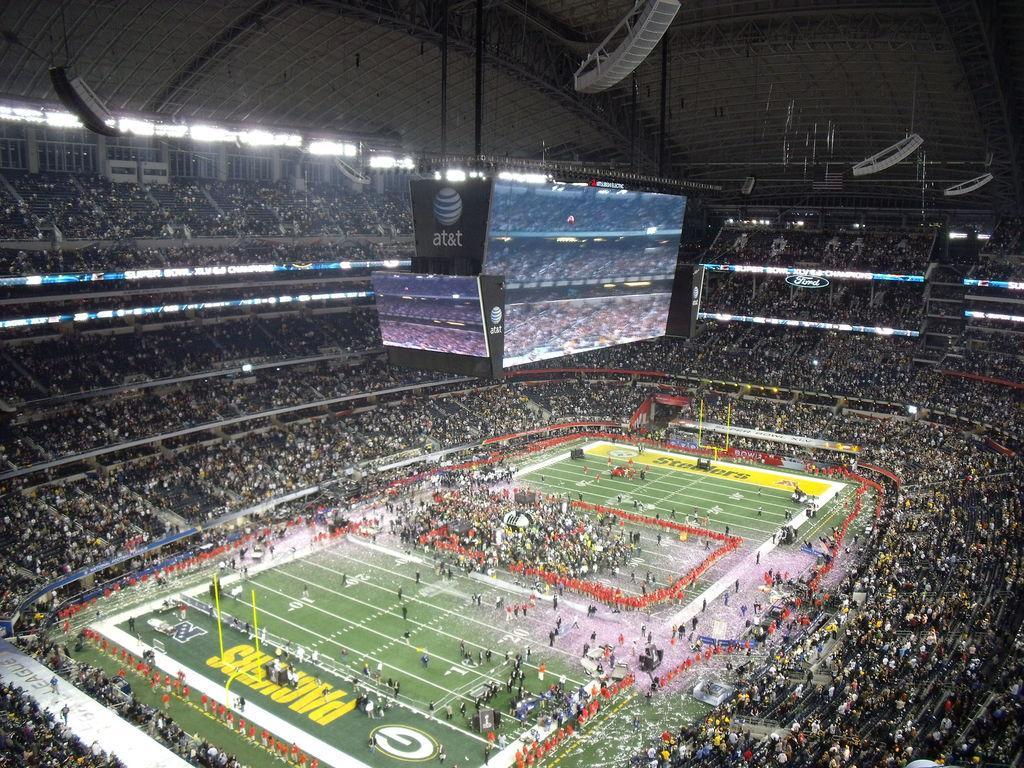How would you summarize this image in a sentence or two? In this picture there is a stadium in the image and there are audience around the ground. 